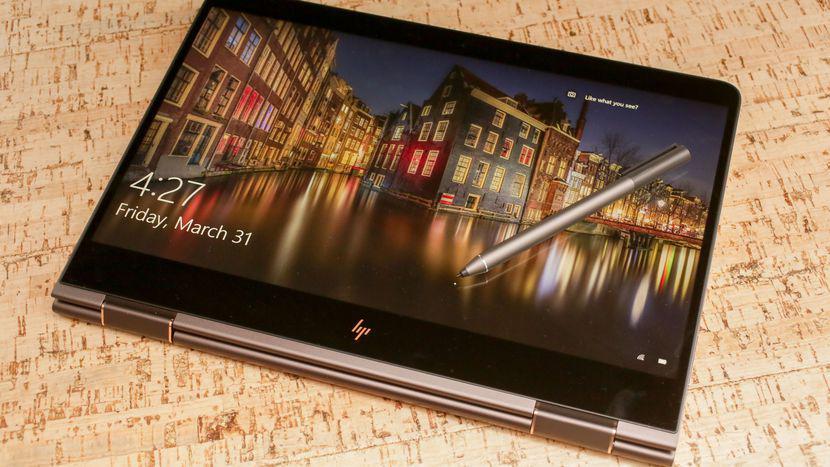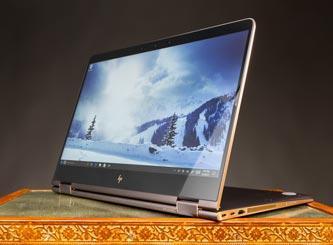The first image is the image on the left, the second image is the image on the right. For the images displayed, is the sentence "At least one image shows a straight-on side view of a laptop that is opened at less than a 45-degree angle." factually correct? Answer yes or no. No. The first image is the image on the left, the second image is the image on the right. Evaluate the accuracy of this statement regarding the images: "Two laptop computers are only partially opened, not far enough for a person to use, but far enough to see each has a full keyboard, and below it, a touch pad.". Is it true? Answer yes or no. No. 